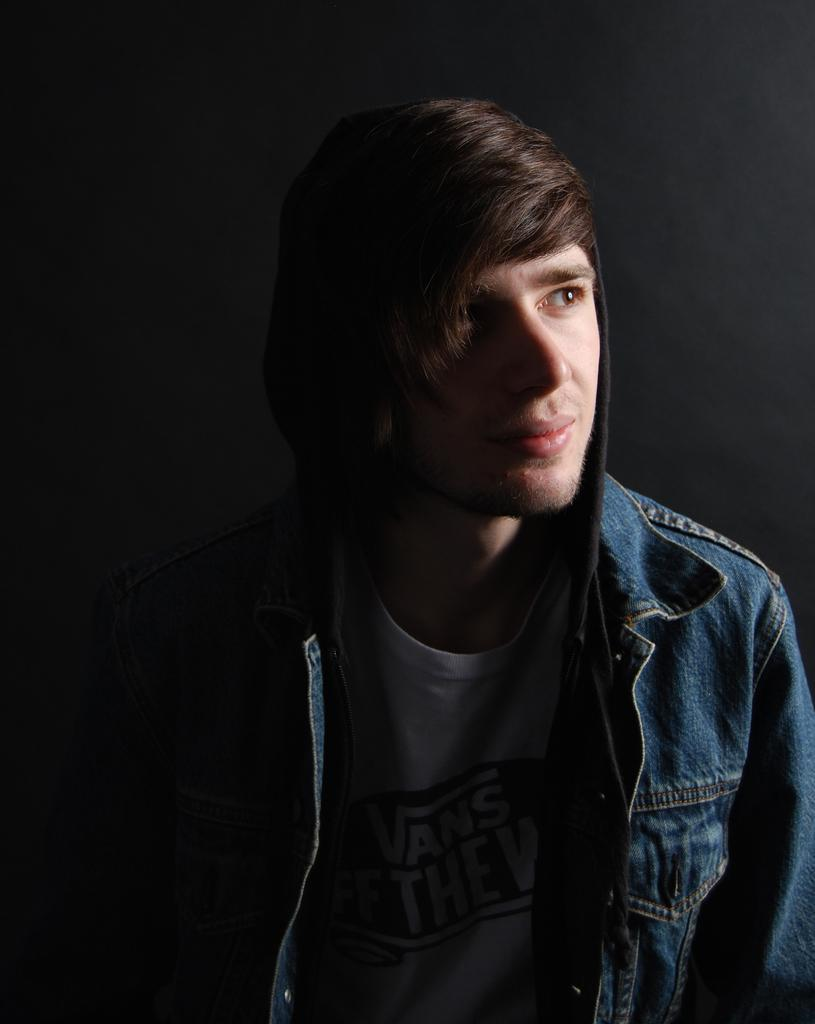What direction is the person in the image looking? The person is looking to the right side of the image. What type of clothing is the person wearing? The person is wearing a jacket. What can be observed about the lighting in the image? The background of the image is dark. What type of credit card is the person holding in the image? There is no credit card visible in the image; the person is simply looking to the right side. How many wheels can be seen on the person in the image? The person is not a vehicle or object with wheels, so no wheels are visible. 